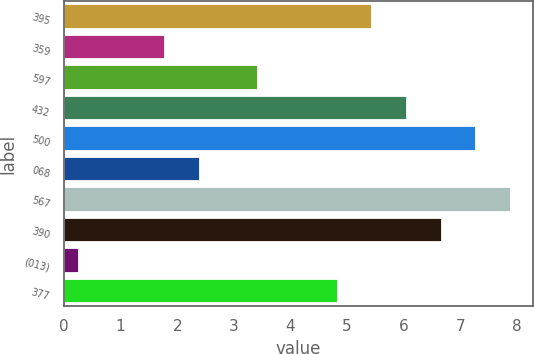<chart> <loc_0><loc_0><loc_500><loc_500><bar_chart><fcel>395<fcel>359<fcel>597<fcel>432<fcel>500<fcel>068<fcel>567<fcel>390<fcel>(013)<fcel>377<nl><fcel>5.45<fcel>1.79<fcel>3.43<fcel>6.06<fcel>7.28<fcel>2.4<fcel>7.89<fcel>6.67<fcel>0.26<fcel>4.84<nl></chart> 